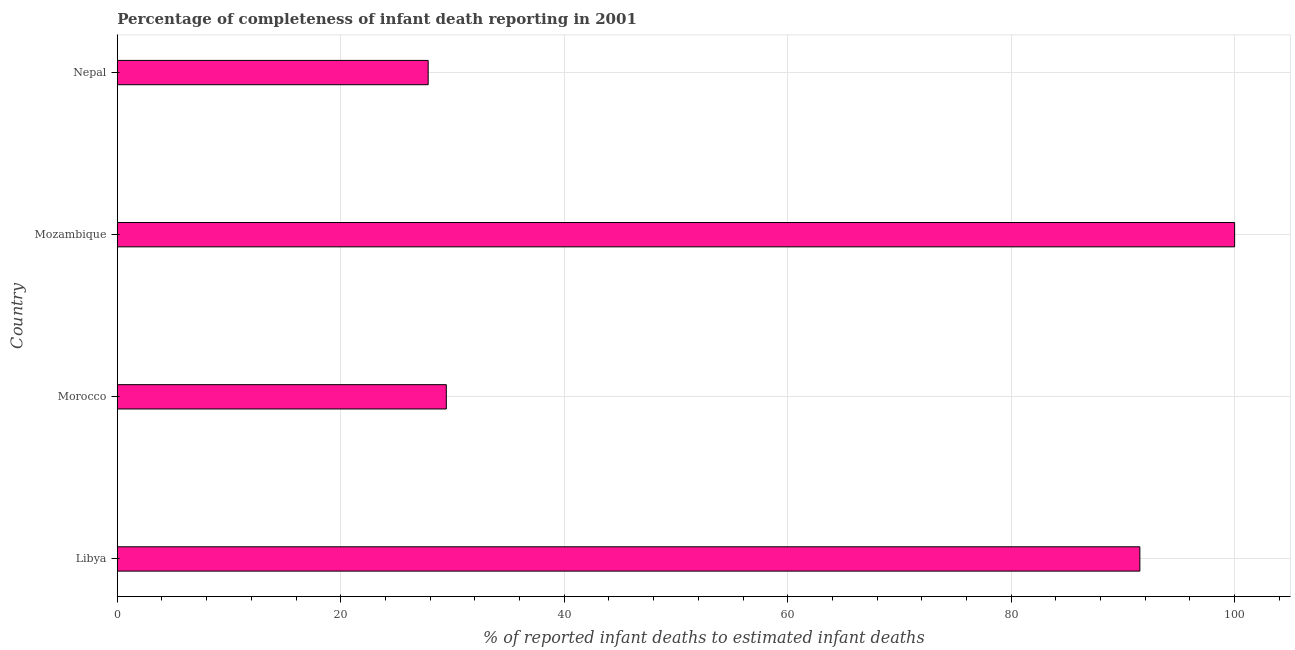Does the graph contain grids?
Your response must be concise. Yes. What is the title of the graph?
Your answer should be very brief. Percentage of completeness of infant death reporting in 2001. What is the label or title of the X-axis?
Offer a terse response. % of reported infant deaths to estimated infant deaths. What is the completeness of infant death reporting in Morocco?
Your answer should be compact. 29.45. Across all countries, what is the maximum completeness of infant death reporting?
Make the answer very short. 100. Across all countries, what is the minimum completeness of infant death reporting?
Give a very brief answer. 27.82. In which country was the completeness of infant death reporting maximum?
Provide a succinct answer. Mozambique. In which country was the completeness of infant death reporting minimum?
Make the answer very short. Nepal. What is the sum of the completeness of infant death reporting?
Keep it short and to the point. 248.79. What is the difference between the completeness of infant death reporting in Morocco and Nepal?
Ensure brevity in your answer.  1.62. What is the average completeness of infant death reporting per country?
Offer a very short reply. 62.2. What is the median completeness of infant death reporting?
Your response must be concise. 60.48. What is the ratio of the completeness of infant death reporting in Libya to that in Mozambique?
Your response must be concise. 0.92. Is the completeness of infant death reporting in Libya less than that in Mozambique?
Provide a succinct answer. Yes. What is the difference between the highest and the second highest completeness of infant death reporting?
Your answer should be very brief. 8.48. What is the difference between the highest and the lowest completeness of infant death reporting?
Provide a short and direct response. 72.18. In how many countries, is the completeness of infant death reporting greater than the average completeness of infant death reporting taken over all countries?
Ensure brevity in your answer.  2. Are all the bars in the graph horizontal?
Keep it short and to the point. Yes. How many countries are there in the graph?
Your answer should be compact. 4. Are the values on the major ticks of X-axis written in scientific E-notation?
Give a very brief answer. No. What is the % of reported infant deaths to estimated infant deaths of Libya?
Your answer should be compact. 91.52. What is the % of reported infant deaths to estimated infant deaths in Morocco?
Ensure brevity in your answer.  29.45. What is the % of reported infant deaths to estimated infant deaths of Mozambique?
Ensure brevity in your answer.  100. What is the % of reported infant deaths to estimated infant deaths of Nepal?
Give a very brief answer. 27.82. What is the difference between the % of reported infant deaths to estimated infant deaths in Libya and Morocco?
Offer a very short reply. 62.07. What is the difference between the % of reported infant deaths to estimated infant deaths in Libya and Mozambique?
Your response must be concise. -8.48. What is the difference between the % of reported infant deaths to estimated infant deaths in Libya and Nepal?
Give a very brief answer. 63.69. What is the difference between the % of reported infant deaths to estimated infant deaths in Morocco and Mozambique?
Make the answer very short. -70.55. What is the difference between the % of reported infant deaths to estimated infant deaths in Morocco and Nepal?
Your answer should be compact. 1.62. What is the difference between the % of reported infant deaths to estimated infant deaths in Mozambique and Nepal?
Provide a short and direct response. 72.18. What is the ratio of the % of reported infant deaths to estimated infant deaths in Libya to that in Morocco?
Give a very brief answer. 3.11. What is the ratio of the % of reported infant deaths to estimated infant deaths in Libya to that in Mozambique?
Your answer should be very brief. 0.92. What is the ratio of the % of reported infant deaths to estimated infant deaths in Libya to that in Nepal?
Offer a terse response. 3.29. What is the ratio of the % of reported infant deaths to estimated infant deaths in Morocco to that in Mozambique?
Give a very brief answer. 0.29. What is the ratio of the % of reported infant deaths to estimated infant deaths in Morocco to that in Nepal?
Make the answer very short. 1.06. What is the ratio of the % of reported infant deaths to estimated infant deaths in Mozambique to that in Nepal?
Your answer should be compact. 3.59. 